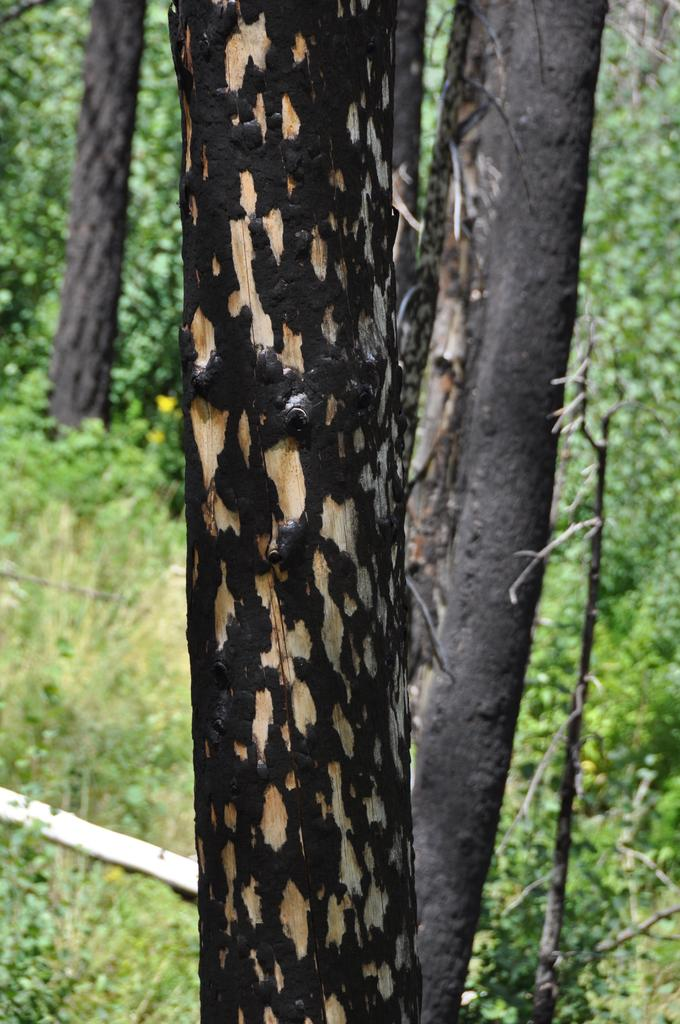What type of vegetation can be seen in the image? There is a group of trees and plants in the image. Can you describe the trees in the image? The group of trees in the image consists of various types and sizes. What else can be seen in the image besides the trees and plants? The provided facts do not mention any other objects or subjects in the image. What color is the sofa in the image? There is no sofa present in the image. How many bubbles can be seen floating around the plants in the image? There are no bubbles present in the image. 